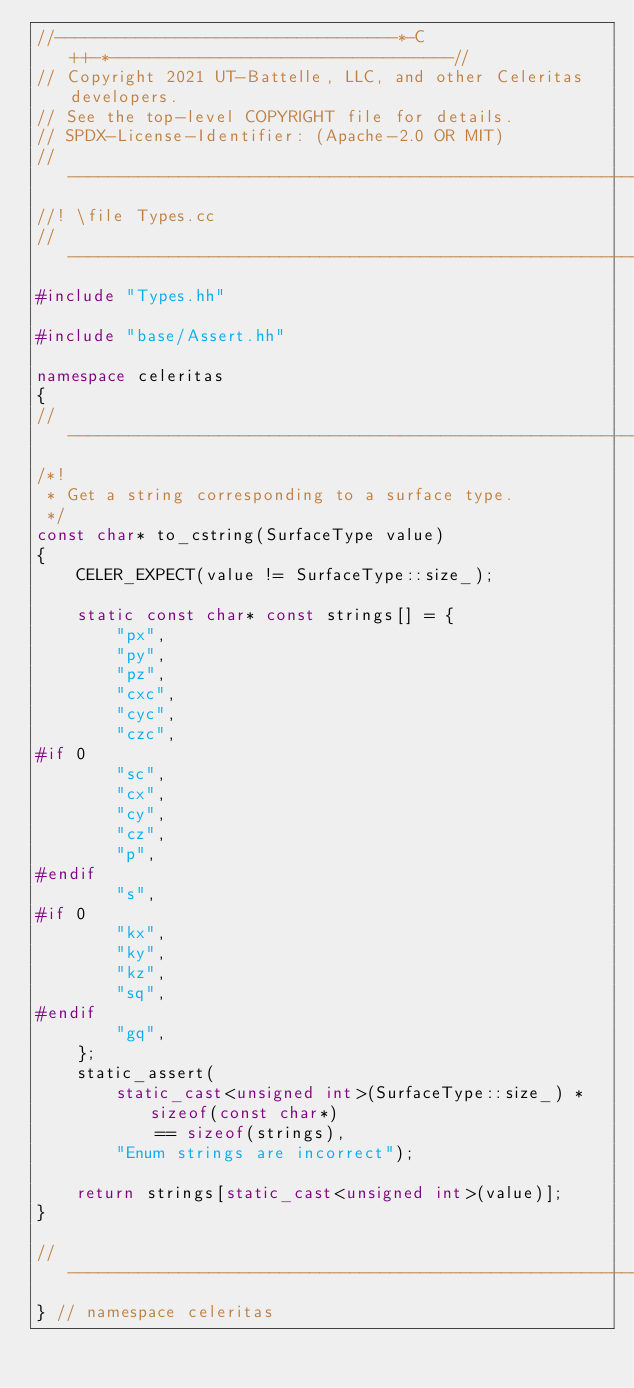Convert code to text. <code><loc_0><loc_0><loc_500><loc_500><_C++_>//----------------------------------*-C++-*----------------------------------//
// Copyright 2021 UT-Battelle, LLC, and other Celeritas developers.
// See the top-level COPYRIGHT file for details.
// SPDX-License-Identifier: (Apache-2.0 OR MIT)
//---------------------------------------------------------------------------//
//! \file Types.cc
//---------------------------------------------------------------------------//
#include "Types.hh"

#include "base/Assert.hh"

namespace celeritas
{
//---------------------------------------------------------------------------//
/*!
 * Get a string corresponding to a surface type.
 */
const char* to_cstring(SurfaceType value)
{
    CELER_EXPECT(value != SurfaceType::size_);

    static const char* const strings[] = {
        "px",
        "py",
        "pz",
        "cxc",
        "cyc",
        "czc",
#if 0
        "sc",
        "cx",
        "cy",
        "cz",
        "p",
#endif
        "s",
#if 0
        "kx",
        "ky",
        "kz",
        "sq",
#endif
        "gq",
    };
    static_assert(
        static_cast<unsigned int>(SurfaceType::size_) * sizeof(const char*)
            == sizeof(strings),
        "Enum strings are incorrect");

    return strings[static_cast<unsigned int>(value)];
}

//---------------------------------------------------------------------------//
} // namespace celeritas
</code> 